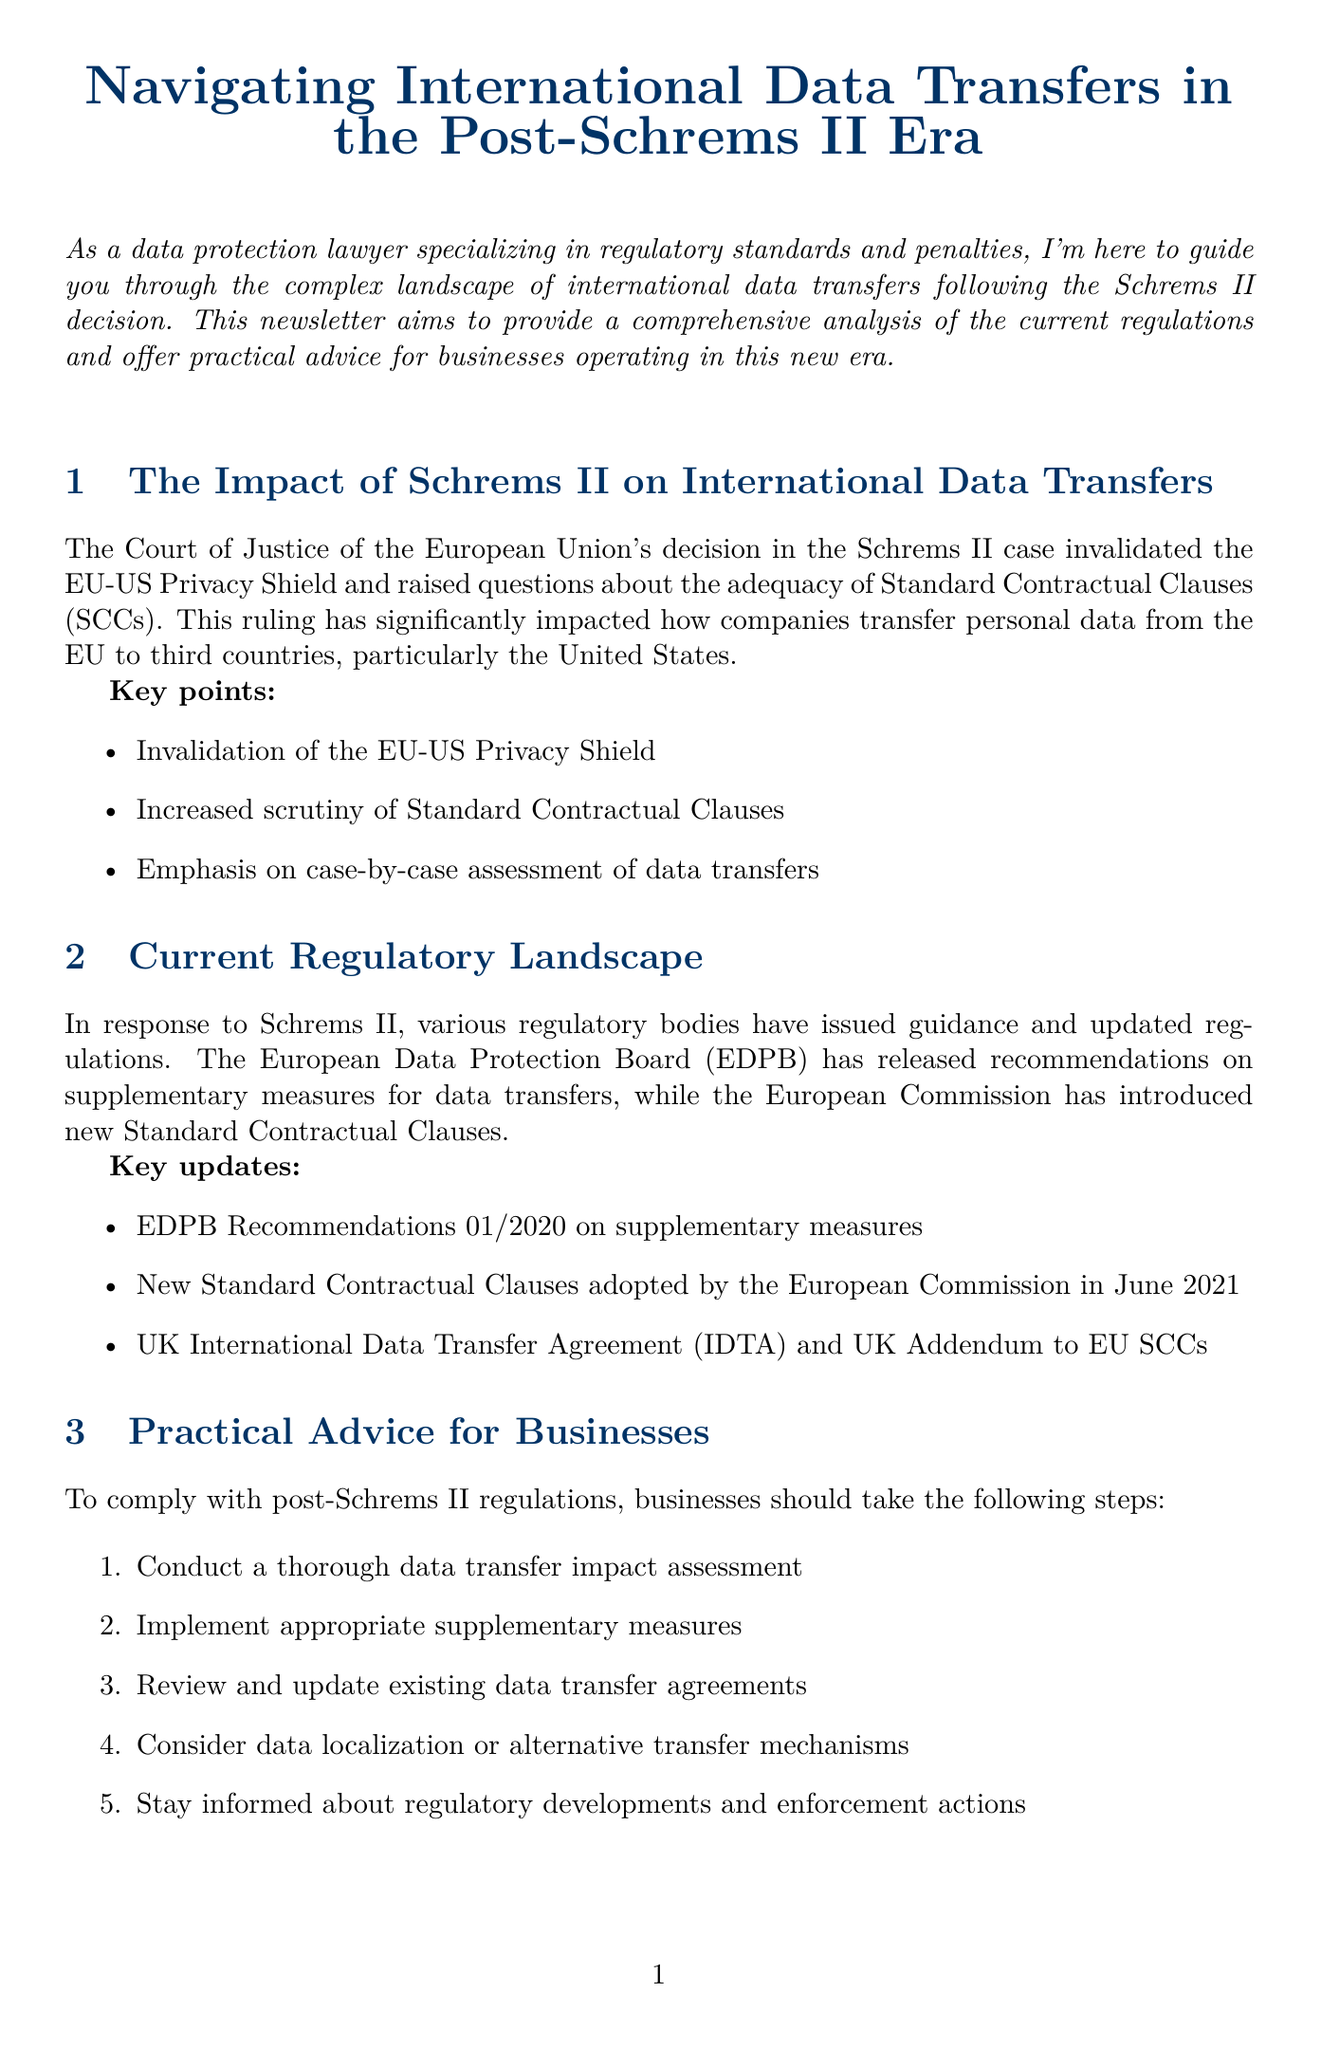What is the title of the newsletter? The title of the newsletter is stated at the beginning of the document.
Answer: Navigating International Data Transfers in the Post-Schrems II Era Who is the author of the newsletter? The author's name and title are mentioned in the "About the Author" section.
Answer: Jane Smith What major data transfer framework was invalidated by the Schrems II decision? The newsletter discusses the impact of the Schrems II decision on existing frameworks.
Answer: EU-US Privacy Shield What significant fine did Amazon incur according to the case studies? The newsletter provides specific details about the fines imposed in the case studies section.
Answer: €746 million What should businesses conduct according to practical advice? The document outlines steps businesses should take to comply with the new regulations.
Answer: A thorough data transfer impact assessment What recommendation was released by the EDPB in response to Schrems II? The newsletter highlights updated guidance from regulatory bodies related to the decision.
Answer: Recommendations 01/2020 on supplementary measures How many steps are suggested for businesses to comply with post-Schrems II regulations? The practical advice section lists the number of steps businesses should follow.
Answer: Five steps What outcome does Facebook face regarding its data transfers? The case studies section describes ongoing issues for specific companies concerning data transfers.
Answer: Potential suspension of transatlantic data flows What is the future development being watched regarding data transfer frameworks? The "Future Outlook" section discusses anticipated developments in data transfer regulations.
Answer: Ongoing negotiations for a new EU-US data transfer framework 